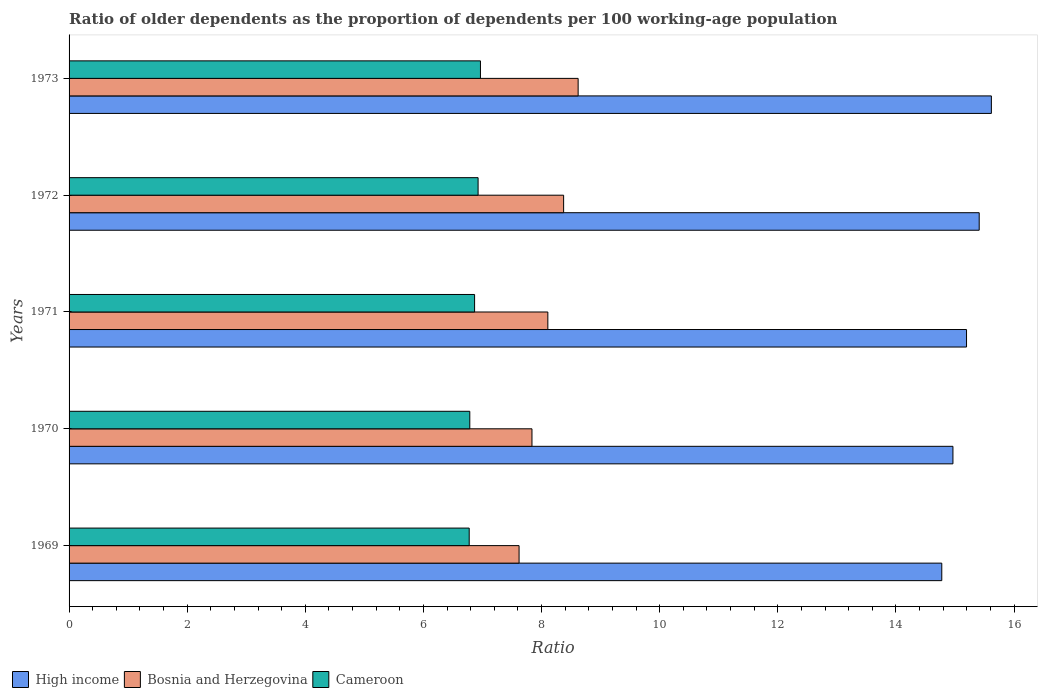How many different coloured bars are there?
Ensure brevity in your answer.  3. Are the number of bars per tick equal to the number of legend labels?
Ensure brevity in your answer.  Yes. What is the label of the 5th group of bars from the top?
Your response must be concise. 1969. In how many cases, is the number of bars for a given year not equal to the number of legend labels?
Give a very brief answer. 0. What is the age dependency ratio(old) in Cameroon in 1971?
Ensure brevity in your answer.  6.87. Across all years, what is the maximum age dependency ratio(old) in High income?
Your answer should be compact. 15.62. Across all years, what is the minimum age dependency ratio(old) in High income?
Offer a terse response. 14.78. In which year was the age dependency ratio(old) in Cameroon maximum?
Offer a terse response. 1973. In which year was the age dependency ratio(old) in Bosnia and Herzegovina minimum?
Ensure brevity in your answer.  1969. What is the total age dependency ratio(old) in Bosnia and Herzegovina in the graph?
Your response must be concise. 40.56. What is the difference between the age dependency ratio(old) in High income in 1969 and that in 1972?
Your answer should be compact. -0.63. What is the difference between the age dependency ratio(old) in Bosnia and Herzegovina in 1970 and the age dependency ratio(old) in Cameroon in 1973?
Your answer should be very brief. 0.87. What is the average age dependency ratio(old) in High income per year?
Provide a short and direct response. 15.19. In the year 1973, what is the difference between the age dependency ratio(old) in Cameroon and age dependency ratio(old) in Bosnia and Herzegovina?
Keep it short and to the point. -1.65. What is the ratio of the age dependency ratio(old) in High income in 1969 to that in 1972?
Ensure brevity in your answer.  0.96. Is the age dependency ratio(old) in Cameroon in 1970 less than that in 1972?
Your response must be concise. Yes. What is the difference between the highest and the second highest age dependency ratio(old) in Cameroon?
Offer a very short reply. 0.04. What is the difference between the highest and the lowest age dependency ratio(old) in High income?
Your answer should be very brief. 0.84. What does the 2nd bar from the top in 1969 represents?
Offer a terse response. Bosnia and Herzegovina. What does the 1st bar from the bottom in 1973 represents?
Give a very brief answer. High income. Is it the case that in every year, the sum of the age dependency ratio(old) in High income and age dependency ratio(old) in Cameroon is greater than the age dependency ratio(old) in Bosnia and Herzegovina?
Your response must be concise. Yes. Does the graph contain any zero values?
Provide a short and direct response. No. Does the graph contain grids?
Give a very brief answer. No. How are the legend labels stacked?
Provide a succinct answer. Horizontal. What is the title of the graph?
Give a very brief answer. Ratio of older dependents as the proportion of dependents per 100 working-age population. What is the label or title of the X-axis?
Your answer should be very brief. Ratio. What is the label or title of the Y-axis?
Keep it short and to the point. Years. What is the Ratio of High income in 1969?
Your answer should be compact. 14.78. What is the Ratio in Bosnia and Herzegovina in 1969?
Make the answer very short. 7.62. What is the Ratio in Cameroon in 1969?
Provide a succinct answer. 6.77. What is the Ratio of High income in 1970?
Ensure brevity in your answer.  14.97. What is the Ratio of Bosnia and Herzegovina in 1970?
Provide a short and direct response. 7.84. What is the Ratio in Cameroon in 1970?
Provide a succinct answer. 6.78. What is the Ratio in High income in 1971?
Provide a short and direct response. 15.2. What is the Ratio of Bosnia and Herzegovina in 1971?
Offer a terse response. 8.11. What is the Ratio in Cameroon in 1971?
Give a very brief answer. 6.87. What is the Ratio in High income in 1972?
Make the answer very short. 15.41. What is the Ratio in Bosnia and Herzegovina in 1972?
Offer a terse response. 8.37. What is the Ratio in Cameroon in 1972?
Your answer should be very brief. 6.93. What is the Ratio of High income in 1973?
Your answer should be very brief. 15.62. What is the Ratio in Bosnia and Herzegovina in 1973?
Your response must be concise. 8.62. What is the Ratio in Cameroon in 1973?
Make the answer very short. 6.97. Across all years, what is the maximum Ratio in High income?
Give a very brief answer. 15.62. Across all years, what is the maximum Ratio in Bosnia and Herzegovina?
Your answer should be compact. 8.62. Across all years, what is the maximum Ratio of Cameroon?
Make the answer very short. 6.97. Across all years, what is the minimum Ratio of High income?
Offer a very short reply. 14.78. Across all years, what is the minimum Ratio in Bosnia and Herzegovina?
Keep it short and to the point. 7.62. Across all years, what is the minimum Ratio in Cameroon?
Your response must be concise. 6.77. What is the total Ratio of High income in the graph?
Give a very brief answer. 75.96. What is the total Ratio of Bosnia and Herzegovina in the graph?
Your answer should be very brief. 40.56. What is the total Ratio of Cameroon in the graph?
Your response must be concise. 34.32. What is the difference between the Ratio of High income in 1969 and that in 1970?
Provide a short and direct response. -0.19. What is the difference between the Ratio in Bosnia and Herzegovina in 1969 and that in 1970?
Ensure brevity in your answer.  -0.22. What is the difference between the Ratio of Cameroon in 1969 and that in 1970?
Provide a succinct answer. -0.01. What is the difference between the Ratio of High income in 1969 and that in 1971?
Provide a succinct answer. -0.42. What is the difference between the Ratio in Bosnia and Herzegovina in 1969 and that in 1971?
Offer a terse response. -0.49. What is the difference between the Ratio of Cameroon in 1969 and that in 1971?
Provide a short and direct response. -0.09. What is the difference between the Ratio in High income in 1969 and that in 1972?
Offer a terse response. -0.63. What is the difference between the Ratio of Bosnia and Herzegovina in 1969 and that in 1972?
Provide a succinct answer. -0.75. What is the difference between the Ratio of Cameroon in 1969 and that in 1972?
Provide a short and direct response. -0.15. What is the difference between the Ratio in High income in 1969 and that in 1973?
Your response must be concise. -0.84. What is the difference between the Ratio of Bosnia and Herzegovina in 1969 and that in 1973?
Provide a succinct answer. -1. What is the difference between the Ratio of Cameroon in 1969 and that in 1973?
Provide a short and direct response. -0.19. What is the difference between the Ratio of High income in 1970 and that in 1971?
Your answer should be compact. -0.23. What is the difference between the Ratio in Bosnia and Herzegovina in 1970 and that in 1971?
Provide a succinct answer. -0.27. What is the difference between the Ratio of Cameroon in 1970 and that in 1971?
Ensure brevity in your answer.  -0.08. What is the difference between the Ratio in High income in 1970 and that in 1972?
Your response must be concise. -0.44. What is the difference between the Ratio in Bosnia and Herzegovina in 1970 and that in 1972?
Your response must be concise. -0.54. What is the difference between the Ratio of Cameroon in 1970 and that in 1972?
Make the answer very short. -0.14. What is the difference between the Ratio in High income in 1970 and that in 1973?
Provide a short and direct response. -0.65. What is the difference between the Ratio in Bosnia and Herzegovina in 1970 and that in 1973?
Keep it short and to the point. -0.78. What is the difference between the Ratio in Cameroon in 1970 and that in 1973?
Your response must be concise. -0.18. What is the difference between the Ratio in High income in 1971 and that in 1972?
Make the answer very short. -0.21. What is the difference between the Ratio in Bosnia and Herzegovina in 1971 and that in 1972?
Make the answer very short. -0.27. What is the difference between the Ratio in Cameroon in 1971 and that in 1972?
Provide a succinct answer. -0.06. What is the difference between the Ratio of High income in 1971 and that in 1973?
Keep it short and to the point. -0.42. What is the difference between the Ratio of Bosnia and Herzegovina in 1971 and that in 1973?
Offer a very short reply. -0.51. What is the difference between the Ratio in Cameroon in 1971 and that in 1973?
Offer a very short reply. -0.1. What is the difference between the Ratio in High income in 1972 and that in 1973?
Keep it short and to the point. -0.21. What is the difference between the Ratio in Bosnia and Herzegovina in 1972 and that in 1973?
Make the answer very short. -0.25. What is the difference between the Ratio of Cameroon in 1972 and that in 1973?
Offer a very short reply. -0.04. What is the difference between the Ratio in High income in 1969 and the Ratio in Bosnia and Herzegovina in 1970?
Give a very brief answer. 6.94. What is the difference between the Ratio of High income in 1969 and the Ratio of Cameroon in 1970?
Your response must be concise. 7.99. What is the difference between the Ratio of Bosnia and Herzegovina in 1969 and the Ratio of Cameroon in 1970?
Your response must be concise. 0.83. What is the difference between the Ratio of High income in 1969 and the Ratio of Bosnia and Herzegovina in 1971?
Ensure brevity in your answer.  6.67. What is the difference between the Ratio of High income in 1969 and the Ratio of Cameroon in 1971?
Your answer should be very brief. 7.91. What is the difference between the Ratio in Bosnia and Herzegovina in 1969 and the Ratio in Cameroon in 1971?
Ensure brevity in your answer.  0.75. What is the difference between the Ratio of High income in 1969 and the Ratio of Bosnia and Herzegovina in 1972?
Ensure brevity in your answer.  6.4. What is the difference between the Ratio of High income in 1969 and the Ratio of Cameroon in 1972?
Provide a succinct answer. 7.85. What is the difference between the Ratio of Bosnia and Herzegovina in 1969 and the Ratio of Cameroon in 1972?
Provide a succinct answer. 0.69. What is the difference between the Ratio of High income in 1969 and the Ratio of Bosnia and Herzegovina in 1973?
Make the answer very short. 6.16. What is the difference between the Ratio of High income in 1969 and the Ratio of Cameroon in 1973?
Your response must be concise. 7.81. What is the difference between the Ratio in Bosnia and Herzegovina in 1969 and the Ratio in Cameroon in 1973?
Keep it short and to the point. 0.65. What is the difference between the Ratio in High income in 1970 and the Ratio in Bosnia and Herzegovina in 1971?
Keep it short and to the point. 6.86. What is the difference between the Ratio of High income in 1970 and the Ratio of Cameroon in 1971?
Give a very brief answer. 8.1. What is the difference between the Ratio in Bosnia and Herzegovina in 1970 and the Ratio in Cameroon in 1971?
Keep it short and to the point. 0.97. What is the difference between the Ratio of High income in 1970 and the Ratio of Bosnia and Herzegovina in 1972?
Your response must be concise. 6.59. What is the difference between the Ratio of High income in 1970 and the Ratio of Cameroon in 1972?
Offer a terse response. 8.04. What is the difference between the Ratio in Bosnia and Herzegovina in 1970 and the Ratio in Cameroon in 1972?
Ensure brevity in your answer.  0.91. What is the difference between the Ratio in High income in 1970 and the Ratio in Bosnia and Herzegovina in 1973?
Your answer should be very brief. 6.35. What is the difference between the Ratio in Bosnia and Herzegovina in 1970 and the Ratio in Cameroon in 1973?
Give a very brief answer. 0.87. What is the difference between the Ratio of High income in 1971 and the Ratio of Bosnia and Herzegovina in 1972?
Offer a very short reply. 6.82. What is the difference between the Ratio of High income in 1971 and the Ratio of Cameroon in 1972?
Your answer should be compact. 8.27. What is the difference between the Ratio of Bosnia and Herzegovina in 1971 and the Ratio of Cameroon in 1972?
Provide a short and direct response. 1.18. What is the difference between the Ratio of High income in 1971 and the Ratio of Bosnia and Herzegovina in 1973?
Your answer should be very brief. 6.58. What is the difference between the Ratio of High income in 1971 and the Ratio of Cameroon in 1973?
Your answer should be compact. 8.23. What is the difference between the Ratio in Bosnia and Herzegovina in 1971 and the Ratio in Cameroon in 1973?
Keep it short and to the point. 1.14. What is the difference between the Ratio in High income in 1972 and the Ratio in Bosnia and Herzegovina in 1973?
Give a very brief answer. 6.79. What is the difference between the Ratio of High income in 1972 and the Ratio of Cameroon in 1973?
Your response must be concise. 8.44. What is the difference between the Ratio of Bosnia and Herzegovina in 1972 and the Ratio of Cameroon in 1973?
Your response must be concise. 1.41. What is the average Ratio of High income per year?
Keep it short and to the point. 15.19. What is the average Ratio of Bosnia and Herzegovina per year?
Offer a very short reply. 8.11. What is the average Ratio of Cameroon per year?
Keep it short and to the point. 6.86. In the year 1969, what is the difference between the Ratio of High income and Ratio of Bosnia and Herzegovina?
Keep it short and to the point. 7.16. In the year 1969, what is the difference between the Ratio in High income and Ratio in Cameroon?
Your response must be concise. 8. In the year 1969, what is the difference between the Ratio in Bosnia and Herzegovina and Ratio in Cameroon?
Give a very brief answer. 0.84. In the year 1970, what is the difference between the Ratio in High income and Ratio in Bosnia and Herzegovina?
Provide a succinct answer. 7.13. In the year 1970, what is the difference between the Ratio of High income and Ratio of Cameroon?
Your answer should be compact. 8.18. In the year 1970, what is the difference between the Ratio in Bosnia and Herzegovina and Ratio in Cameroon?
Offer a terse response. 1.05. In the year 1971, what is the difference between the Ratio of High income and Ratio of Bosnia and Herzegovina?
Offer a terse response. 7.09. In the year 1971, what is the difference between the Ratio in High income and Ratio in Cameroon?
Offer a very short reply. 8.33. In the year 1971, what is the difference between the Ratio of Bosnia and Herzegovina and Ratio of Cameroon?
Offer a very short reply. 1.24. In the year 1972, what is the difference between the Ratio of High income and Ratio of Bosnia and Herzegovina?
Give a very brief answer. 7.04. In the year 1972, what is the difference between the Ratio of High income and Ratio of Cameroon?
Offer a terse response. 8.48. In the year 1972, what is the difference between the Ratio in Bosnia and Herzegovina and Ratio in Cameroon?
Ensure brevity in your answer.  1.45. In the year 1973, what is the difference between the Ratio of High income and Ratio of Bosnia and Herzegovina?
Give a very brief answer. 7. In the year 1973, what is the difference between the Ratio in High income and Ratio in Cameroon?
Your answer should be very brief. 8.65. In the year 1973, what is the difference between the Ratio of Bosnia and Herzegovina and Ratio of Cameroon?
Ensure brevity in your answer.  1.65. What is the ratio of the Ratio of High income in 1969 to that in 1970?
Give a very brief answer. 0.99. What is the ratio of the Ratio of Bosnia and Herzegovina in 1969 to that in 1970?
Keep it short and to the point. 0.97. What is the ratio of the Ratio in High income in 1969 to that in 1971?
Make the answer very short. 0.97. What is the ratio of the Ratio of Bosnia and Herzegovina in 1969 to that in 1971?
Provide a succinct answer. 0.94. What is the ratio of the Ratio of Cameroon in 1969 to that in 1971?
Give a very brief answer. 0.99. What is the ratio of the Ratio in High income in 1969 to that in 1972?
Your answer should be compact. 0.96. What is the ratio of the Ratio in Bosnia and Herzegovina in 1969 to that in 1972?
Make the answer very short. 0.91. What is the ratio of the Ratio in Cameroon in 1969 to that in 1972?
Your response must be concise. 0.98. What is the ratio of the Ratio of High income in 1969 to that in 1973?
Offer a very short reply. 0.95. What is the ratio of the Ratio in Bosnia and Herzegovina in 1969 to that in 1973?
Your answer should be compact. 0.88. What is the ratio of the Ratio of Cameroon in 1969 to that in 1973?
Provide a succinct answer. 0.97. What is the ratio of the Ratio of High income in 1970 to that in 1971?
Offer a terse response. 0.98. What is the ratio of the Ratio in Bosnia and Herzegovina in 1970 to that in 1971?
Your answer should be compact. 0.97. What is the ratio of the Ratio of High income in 1970 to that in 1972?
Ensure brevity in your answer.  0.97. What is the ratio of the Ratio in Bosnia and Herzegovina in 1970 to that in 1972?
Your answer should be compact. 0.94. What is the ratio of the Ratio in Cameroon in 1970 to that in 1972?
Provide a short and direct response. 0.98. What is the ratio of the Ratio of High income in 1970 to that in 1973?
Offer a very short reply. 0.96. What is the ratio of the Ratio in Bosnia and Herzegovina in 1970 to that in 1973?
Keep it short and to the point. 0.91. What is the ratio of the Ratio in Cameroon in 1970 to that in 1973?
Give a very brief answer. 0.97. What is the ratio of the Ratio in High income in 1971 to that in 1972?
Ensure brevity in your answer.  0.99. What is the ratio of the Ratio of Bosnia and Herzegovina in 1971 to that in 1972?
Keep it short and to the point. 0.97. What is the ratio of the Ratio in Cameroon in 1971 to that in 1972?
Keep it short and to the point. 0.99. What is the ratio of the Ratio in High income in 1971 to that in 1973?
Ensure brevity in your answer.  0.97. What is the ratio of the Ratio in Bosnia and Herzegovina in 1971 to that in 1973?
Offer a terse response. 0.94. What is the ratio of the Ratio of Cameroon in 1971 to that in 1973?
Make the answer very short. 0.99. What is the ratio of the Ratio in High income in 1972 to that in 1973?
Provide a succinct answer. 0.99. What is the ratio of the Ratio in Bosnia and Herzegovina in 1972 to that in 1973?
Your answer should be compact. 0.97. What is the ratio of the Ratio in Cameroon in 1972 to that in 1973?
Your answer should be very brief. 0.99. What is the difference between the highest and the second highest Ratio in High income?
Ensure brevity in your answer.  0.21. What is the difference between the highest and the second highest Ratio in Bosnia and Herzegovina?
Your answer should be compact. 0.25. What is the difference between the highest and the second highest Ratio in Cameroon?
Provide a short and direct response. 0.04. What is the difference between the highest and the lowest Ratio in High income?
Give a very brief answer. 0.84. What is the difference between the highest and the lowest Ratio of Bosnia and Herzegovina?
Make the answer very short. 1. What is the difference between the highest and the lowest Ratio in Cameroon?
Your response must be concise. 0.19. 